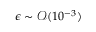<formula> <loc_0><loc_0><loc_500><loc_500>\epsilon \sim \mathcal { O } ( 1 0 ^ { - 3 } )</formula> 